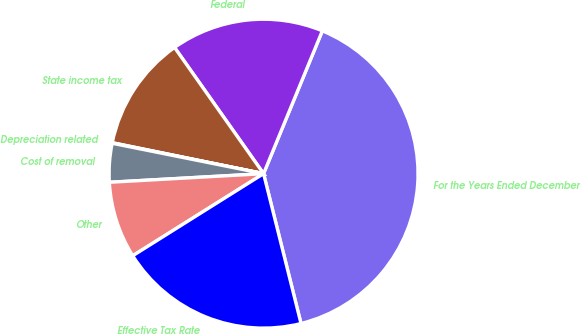Convert chart. <chart><loc_0><loc_0><loc_500><loc_500><pie_chart><fcel>For the Years Ended December<fcel>Federal<fcel>State income tax<fcel>Depreciation related<fcel>Cost of removal<fcel>Other<fcel>Effective Tax Rate<nl><fcel>39.89%<fcel>15.99%<fcel>12.01%<fcel>0.06%<fcel>4.04%<fcel>8.03%<fcel>19.98%<nl></chart> 